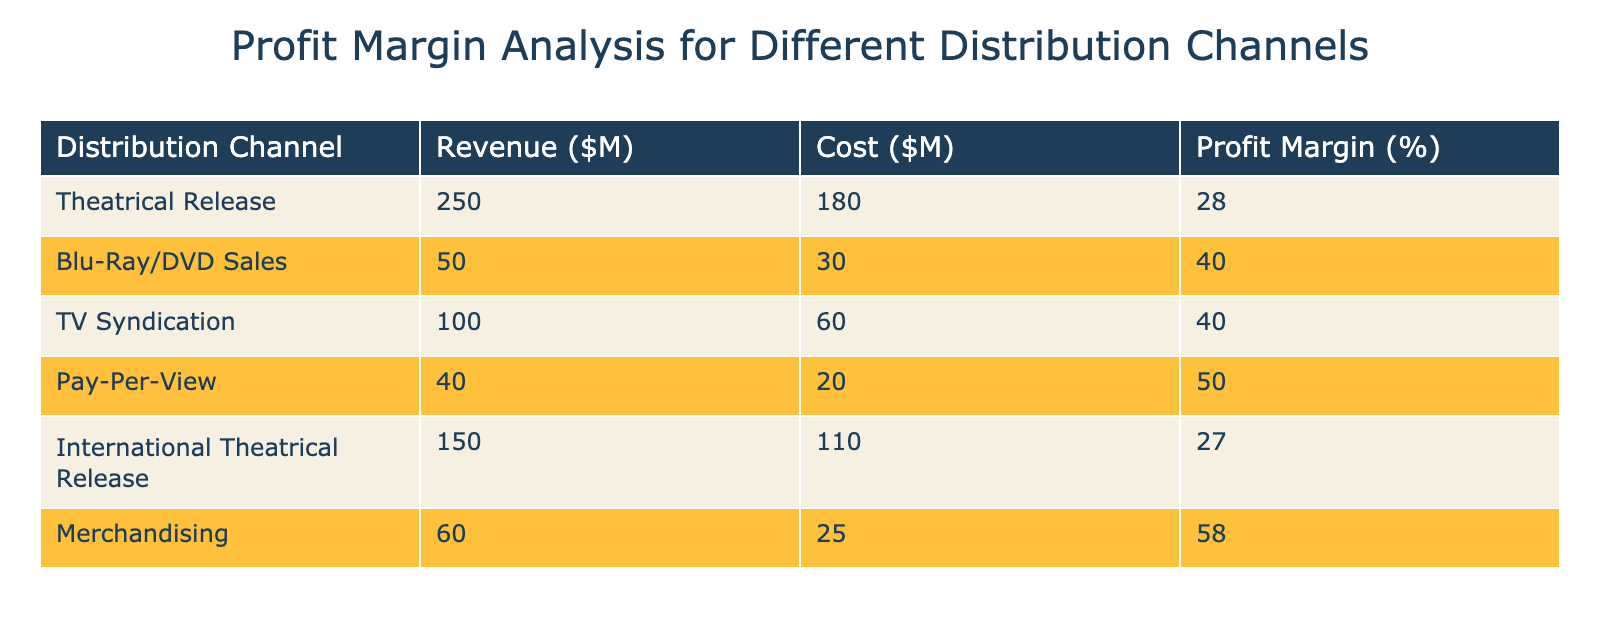What is the profit margin for Blu-Ray/DVD Sales? The profit margin for Blu-Ray/DVD Sales is listed directly in the table. It shows a profit margin of 40%.
Answer: 40% Which distribution channel has the highest revenue? By comparing the revenue figures across all channels, Theatrical Release has the highest revenue at $250 million.
Answer: Theatrical Release What is the total revenue from International Theatrical Release and TV Syndication combined? To find the total revenue, sum the revenue values for International Theatrical Release ($150 million) and TV Syndication ($100 million), giving a total of $250 million.
Answer: 250 million Is the profit margin for Pay-Per-View greater than the profit margin for Theatrical Release? The profit margin for Pay-Per-View is 50%, while the profit margin for Theatrical Release is 28%. Therefore, Pay-Per-View has a greater profit margin.
Answer: Yes What is the average profit margin across all distribution channels? First, add the profit margins: 28 + 40 + 40 + 50 + 27 + 58 = 243. Then divide by the number of channels (6): 243 / 6 = 40.5. Therefore, the average profit margin is 40.5%.
Answer: 40.5% Which channel has the lowest profit margin and what is that margin? By examining the profit margins in the table, International Theatrical Release has the lowest margin at 27%.
Answer: International Theatrical Release, 27% How much higher is the profit margin of Merchandising compared to that of Theatrical Release? The profit margin for Merchandising is 58% and for Theatrical Release, it is 28%. The difference is 58 - 28 = 30%.
Answer: 30% Is the total cost of all distribution channels greater than $400 million? The total cost can be found by summing all the costs: 180 + 30 + 60 + 20 + 110 + 25 = 425. Since 425 is greater than 400, the statement is true.
Answer: Yes What percentage of total revenue comes from the combined Blu-Ray/DVD Sales and Pay-Per-View? First, calculate the total revenue: 250 + 50 + 100 + 40 + 150 + 60 = 650 million. Then sum the revenues from Blu-Ray/DVD Sales (50) and Pay-Per-View (40), giving 90 million. The percentage is (90 / 650) * 100 = 13.85%.
Answer: 13.85% 